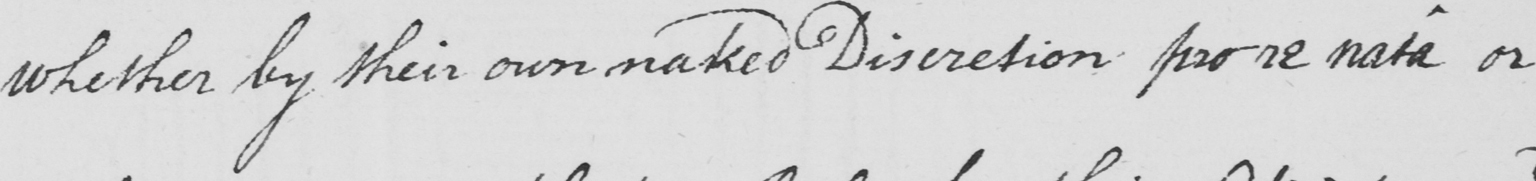Transcribe the text shown in this historical manuscript line. whether by their own naked Discretion pro re nata or 